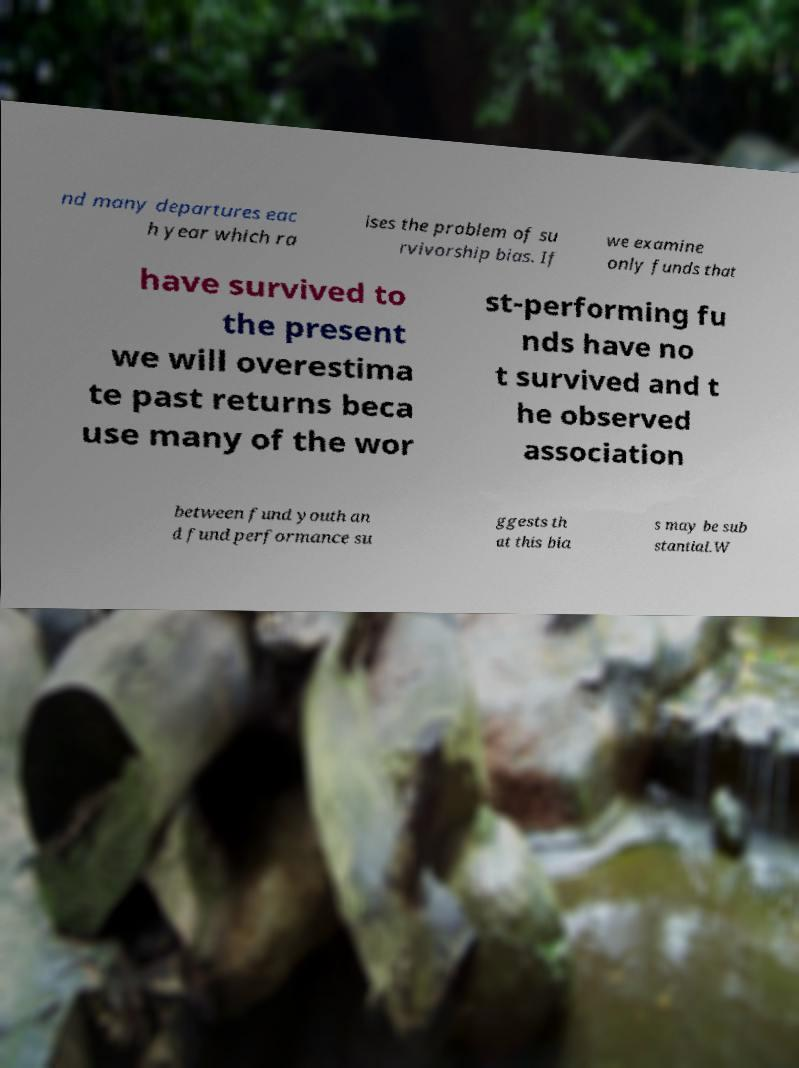Can you read and provide the text displayed in the image?This photo seems to have some interesting text. Can you extract and type it out for me? nd many departures eac h year which ra ises the problem of su rvivorship bias. If we examine only funds that have survived to the present we will overestima te past returns beca use many of the wor st-performing fu nds have no t survived and t he observed association between fund youth an d fund performance su ggests th at this bia s may be sub stantial.W 